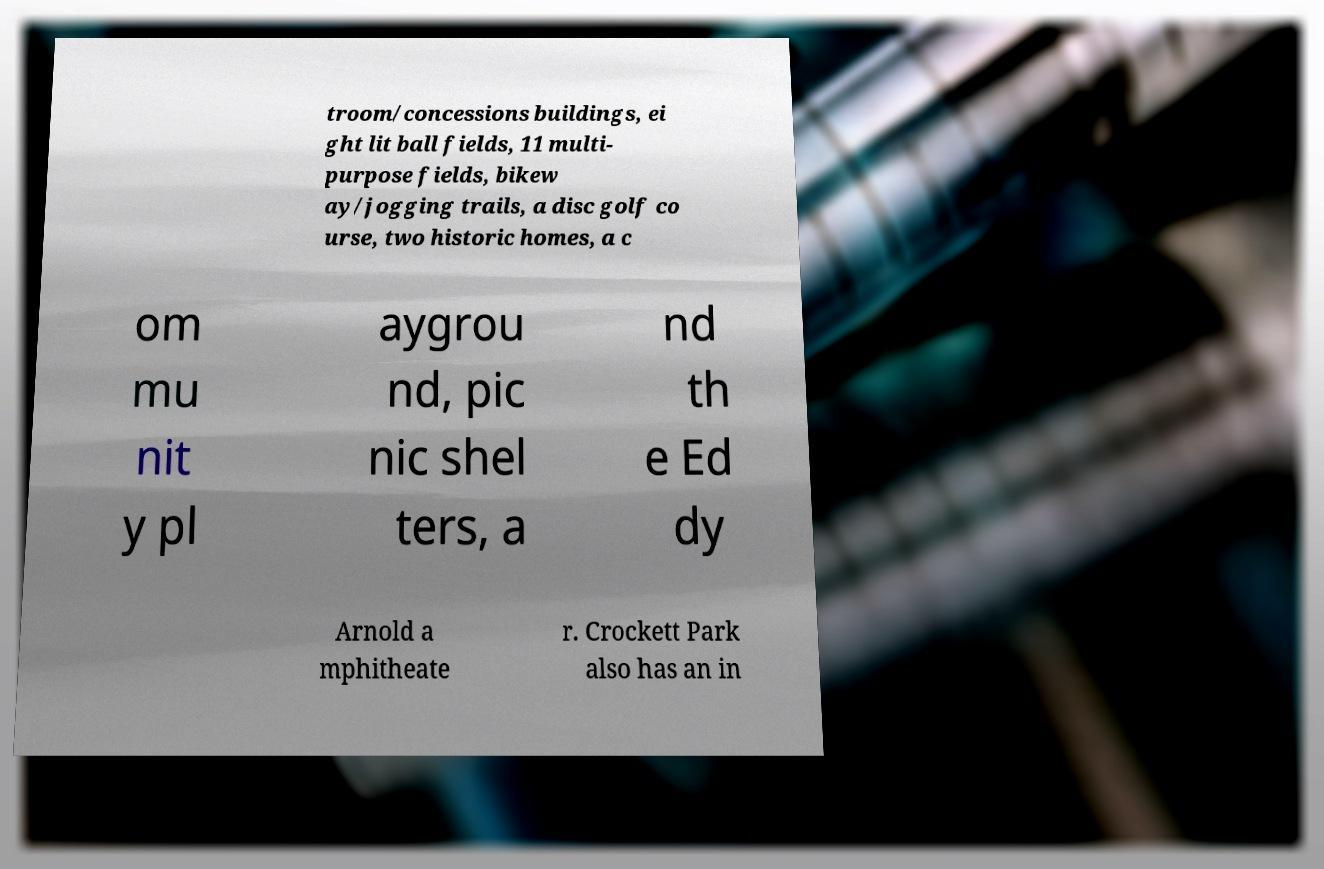There's text embedded in this image that I need extracted. Can you transcribe it verbatim? troom/concessions buildings, ei ght lit ball fields, 11 multi- purpose fields, bikew ay/jogging trails, a disc golf co urse, two historic homes, a c om mu nit y pl aygrou nd, pic nic shel ters, a nd th e Ed dy Arnold a mphitheate r. Crockett Park also has an in 